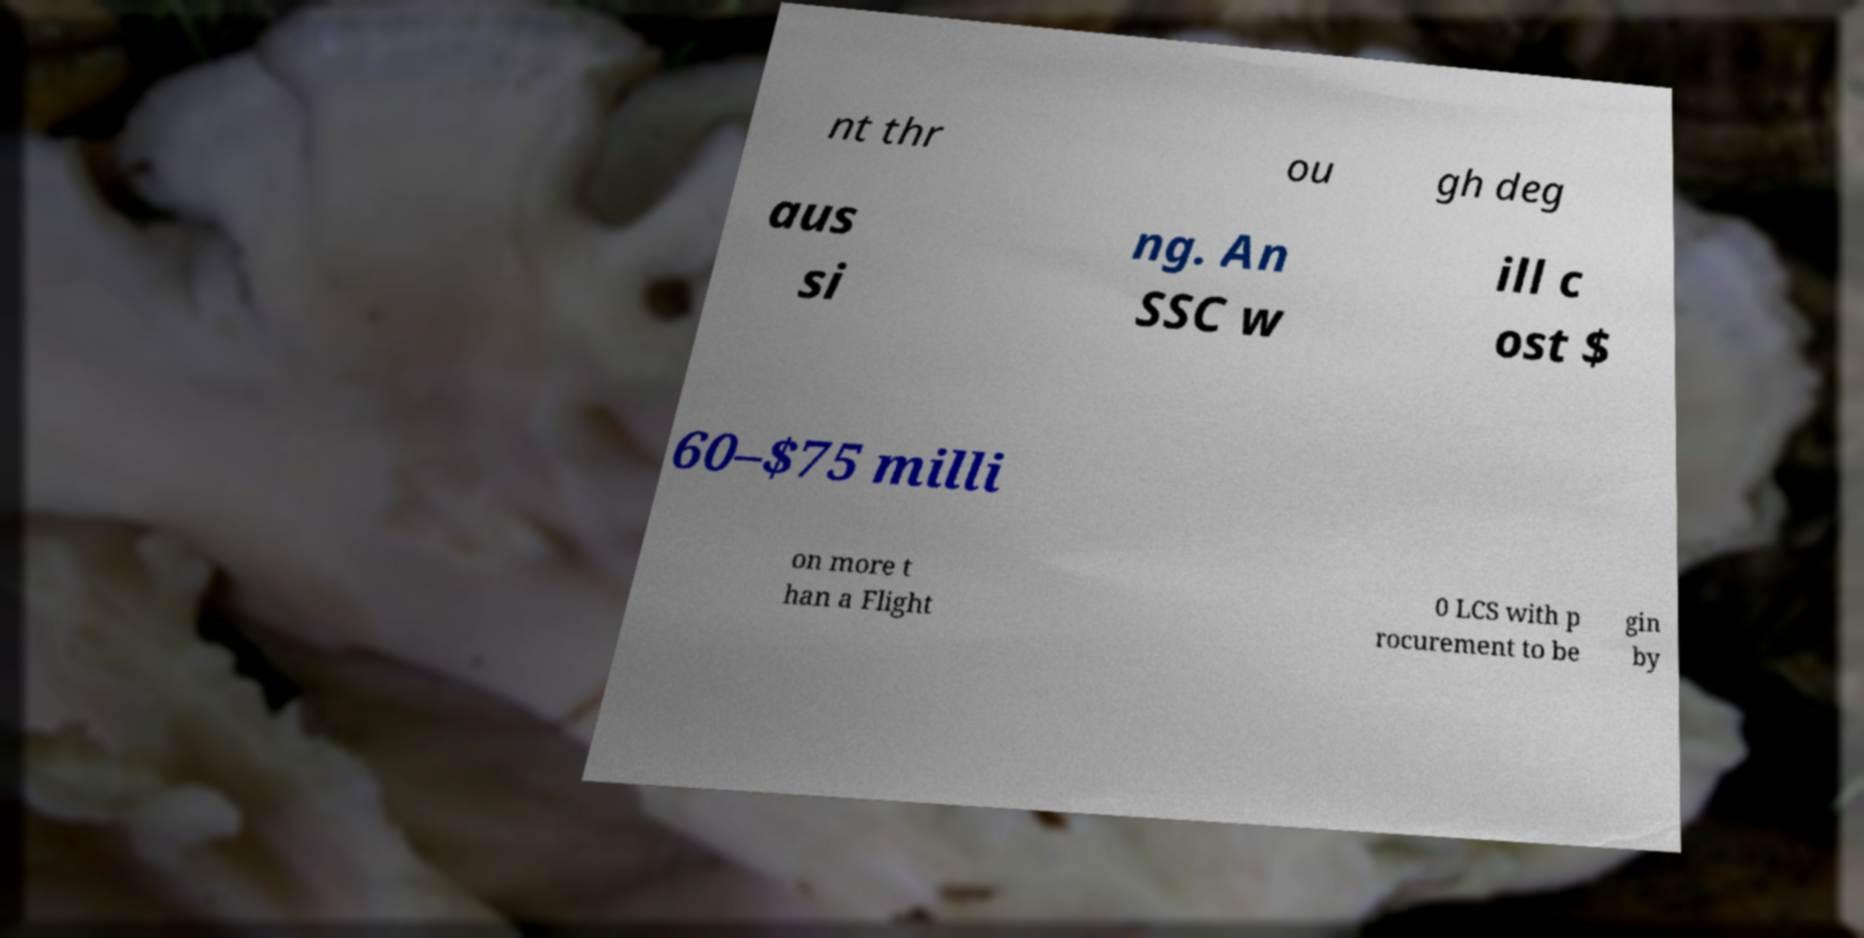Can you read and provide the text displayed in the image?This photo seems to have some interesting text. Can you extract and type it out for me? nt thr ou gh deg aus si ng. An SSC w ill c ost $ 60–$75 milli on more t han a Flight 0 LCS with p rocurement to be gin by 